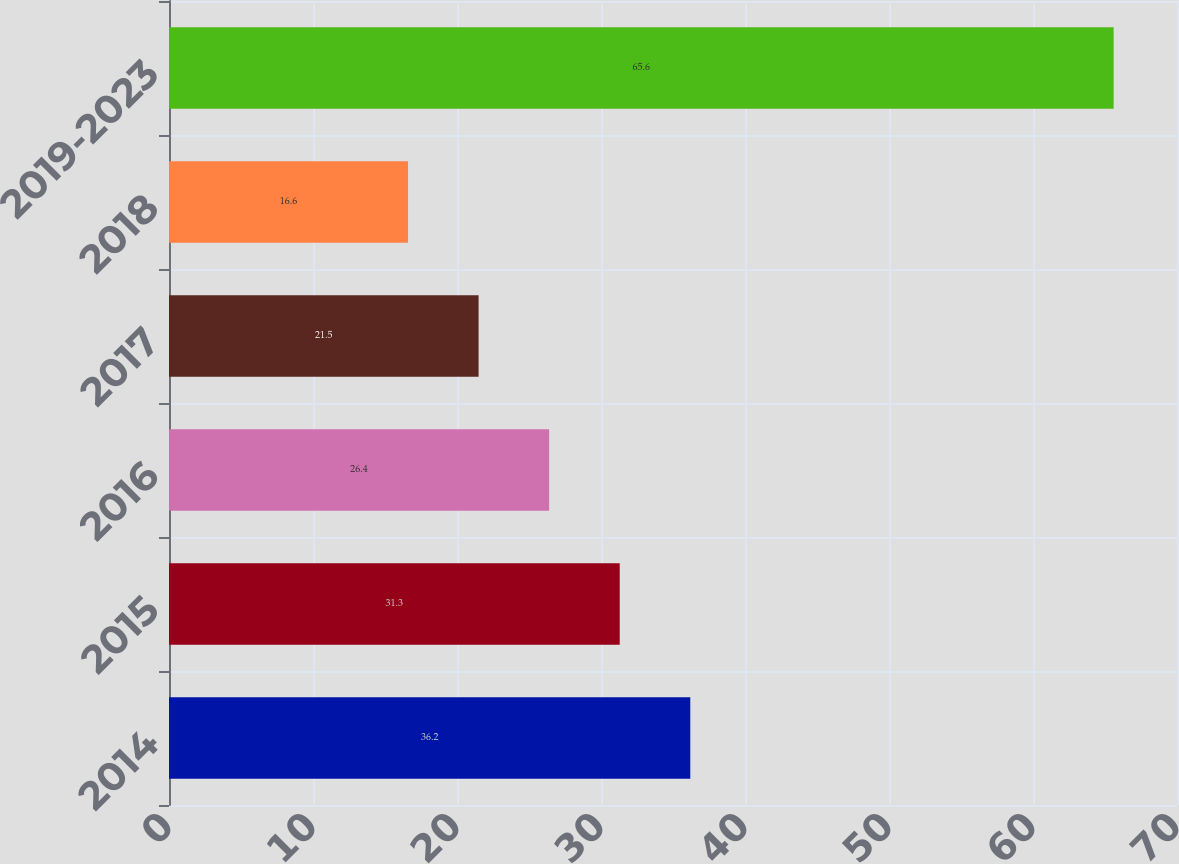Convert chart. <chart><loc_0><loc_0><loc_500><loc_500><bar_chart><fcel>2014<fcel>2015<fcel>2016<fcel>2017<fcel>2018<fcel>2019-2023<nl><fcel>36.2<fcel>31.3<fcel>26.4<fcel>21.5<fcel>16.6<fcel>65.6<nl></chart> 